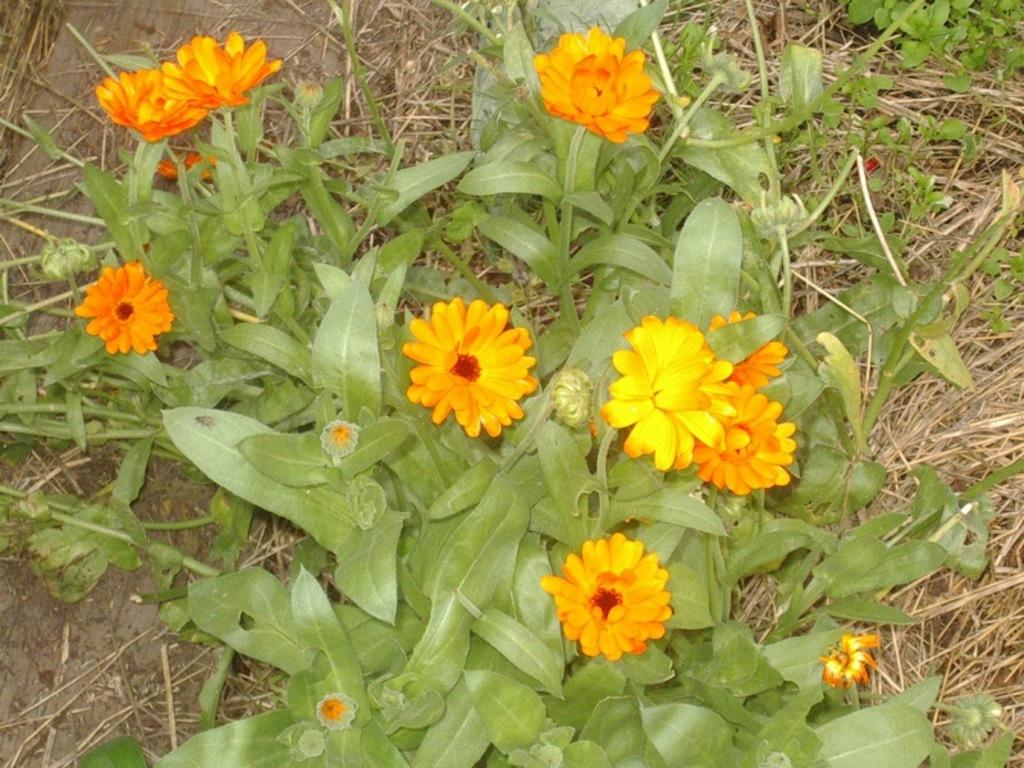What type of living organism can be seen in the image? There is a plant in the image. What is the color of the plant? The plant is green in color. What additional features can be seen on the plant? There are flowers on the plant. What colors are the flowers? The flowers are orange, yellow, and red in color. What type of vegetation is visible on the ground in the image? There is grass visible on the ground in the image. What is the manager's reaction to the shocking news in the image? There is no manager or shocking news present in the image; it features a plant with flowers and grass on the ground. 